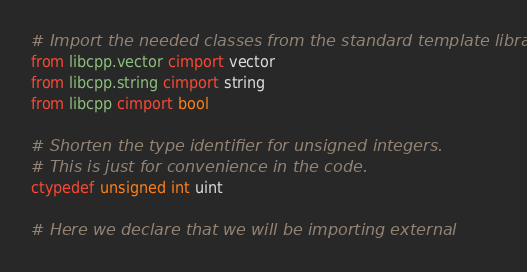<code> <loc_0><loc_0><loc_500><loc_500><_Cython_># Import the needed classes from the standard template library.
from libcpp.vector cimport vector
from libcpp.string cimport string
from libcpp cimport bool

# Shorten the type identifier for unsigned integers.
# This is just for convenience in the code.
ctypedef unsigned int uint

# Here we declare that we will be importing external</code> 